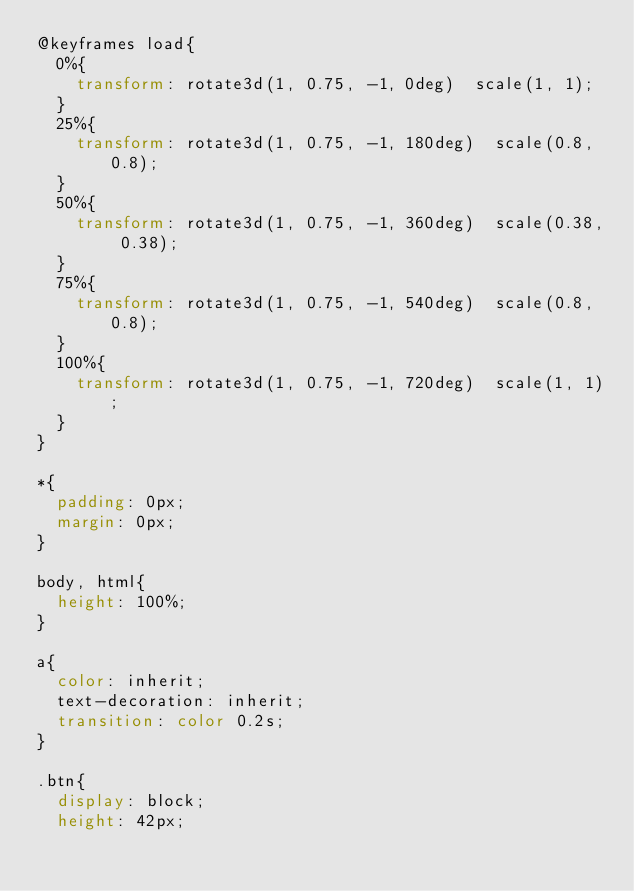<code> <loc_0><loc_0><loc_500><loc_500><_CSS_>@keyframes load{
	0%{
		transform: rotate3d(1, 0.75, -1, 0deg)  scale(1, 1);
	}	
	25%{
		transform: rotate3d(1, 0.75, -1, 180deg)  scale(0.8, 0.8);
	}	
	50%{
		transform: rotate3d(1, 0.75, -1, 360deg)  scale(0.38, 0.38);
	}	
	75%{
		transform: rotate3d(1, 0.75, -1, 540deg)  scale(0.8, 0.8);
	}
	100%{
		transform: rotate3d(1, 0.75, -1, 720deg)  scale(1, 1);
	}
}

*{
	padding: 0px;
	margin: 0px;
}

body, html{
	height: 100%;
}

a{
	color: inherit;
	text-decoration: inherit;
	transition: color 0.2s;
}

.btn{
	display: block;
	height: 42px;</code> 